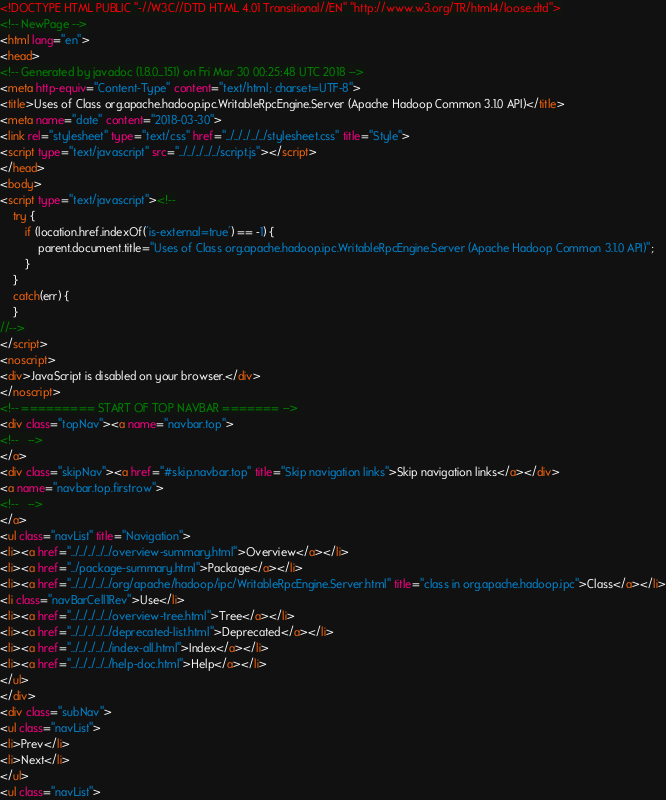<code> <loc_0><loc_0><loc_500><loc_500><_HTML_><!DOCTYPE HTML PUBLIC "-//W3C//DTD HTML 4.01 Transitional//EN" "http://www.w3.org/TR/html4/loose.dtd">
<!-- NewPage -->
<html lang="en">
<head>
<!-- Generated by javadoc (1.8.0_151) on Fri Mar 30 00:25:48 UTC 2018 -->
<meta http-equiv="Content-Type" content="text/html; charset=UTF-8">
<title>Uses of Class org.apache.hadoop.ipc.WritableRpcEngine.Server (Apache Hadoop Common 3.1.0 API)</title>
<meta name="date" content="2018-03-30">
<link rel="stylesheet" type="text/css" href="../../../../../stylesheet.css" title="Style">
<script type="text/javascript" src="../../../../../script.js"></script>
</head>
<body>
<script type="text/javascript"><!--
    try {
        if (location.href.indexOf('is-external=true') == -1) {
            parent.document.title="Uses of Class org.apache.hadoop.ipc.WritableRpcEngine.Server (Apache Hadoop Common 3.1.0 API)";
        }
    }
    catch(err) {
    }
//-->
</script>
<noscript>
<div>JavaScript is disabled on your browser.</div>
</noscript>
<!-- ========= START OF TOP NAVBAR ======= -->
<div class="topNav"><a name="navbar.top">
<!--   -->
</a>
<div class="skipNav"><a href="#skip.navbar.top" title="Skip navigation links">Skip navigation links</a></div>
<a name="navbar.top.firstrow">
<!--   -->
</a>
<ul class="navList" title="Navigation">
<li><a href="../../../../../overview-summary.html">Overview</a></li>
<li><a href="../package-summary.html">Package</a></li>
<li><a href="../../../../../org/apache/hadoop/ipc/WritableRpcEngine.Server.html" title="class in org.apache.hadoop.ipc">Class</a></li>
<li class="navBarCell1Rev">Use</li>
<li><a href="../../../../../overview-tree.html">Tree</a></li>
<li><a href="../../../../../deprecated-list.html">Deprecated</a></li>
<li><a href="../../../../../index-all.html">Index</a></li>
<li><a href="../../../../../help-doc.html">Help</a></li>
</ul>
</div>
<div class="subNav">
<ul class="navList">
<li>Prev</li>
<li>Next</li>
</ul>
<ul class="navList"></code> 